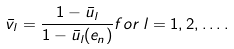Convert formula to latex. <formula><loc_0><loc_0><loc_500><loc_500>\bar { v } _ { l } = \frac { 1 - \bar { u } _ { l } } { 1 - \bar { u } _ { l } ( e _ { n } ) } f o r \, l = 1 , 2 , \dots .</formula> 